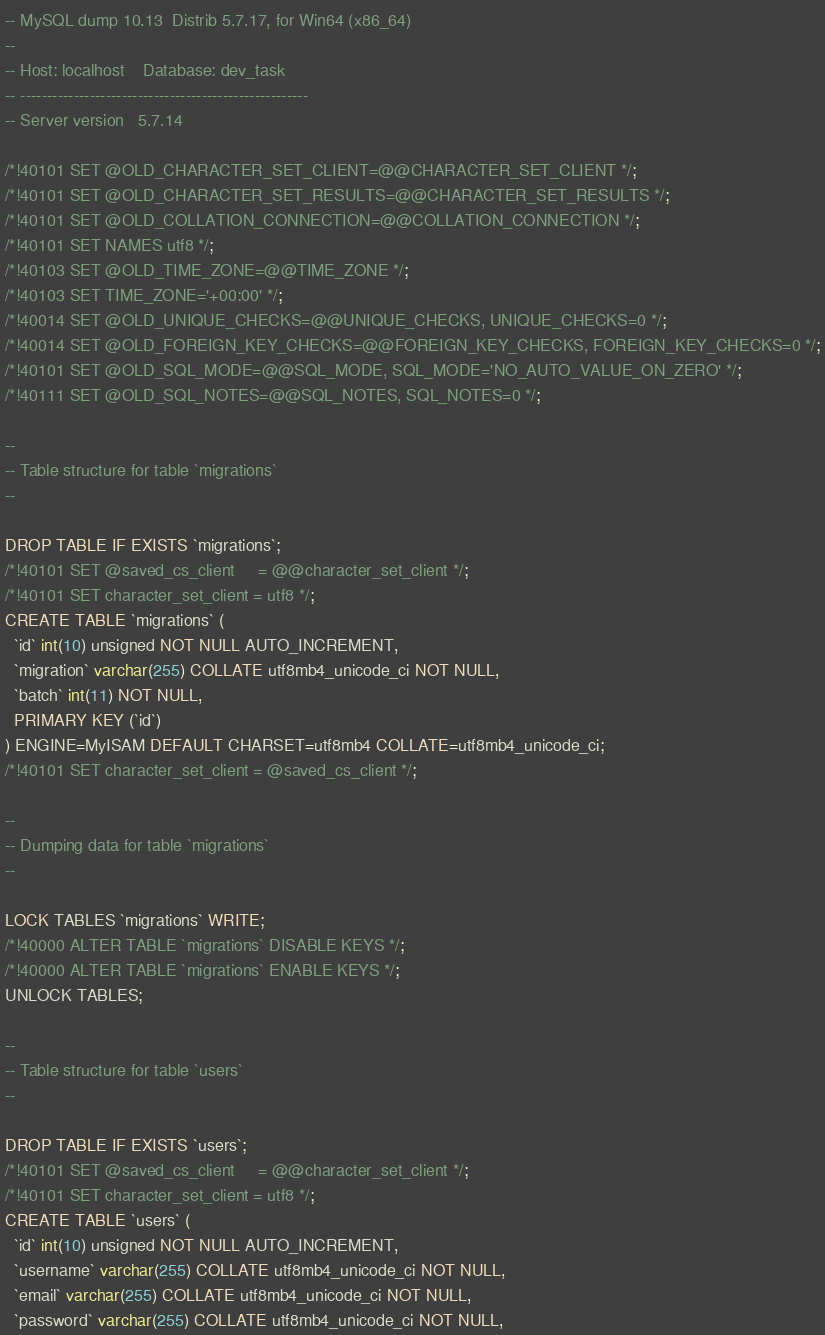Convert code to text. <code><loc_0><loc_0><loc_500><loc_500><_SQL_>-- MySQL dump 10.13  Distrib 5.7.17, for Win64 (x86_64)
--
-- Host: localhost    Database: dev_task
-- ------------------------------------------------------
-- Server version	5.7.14

/*!40101 SET @OLD_CHARACTER_SET_CLIENT=@@CHARACTER_SET_CLIENT */;
/*!40101 SET @OLD_CHARACTER_SET_RESULTS=@@CHARACTER_SET_RESULTS */;
/*!40101 SET @OLD_COLLATION_CONNECTION=@@COLLATION_CONNECTION */;
/*!40101 SET NAMES utf8 */;
/*!40103 SET @OLD_TIME_ZONE=@@TIME_ZONE */;
/*!40103 SET TIME_ZONE='+00:00' */;
/*!40014 SET @OLD_UNIQUE_CHECKS=@@UNIQUE_CHECKS, UNIQUE_CHECKS=0 */;
/*!40014 SET @OLD_FOREIGN_KEY_CHECKS=@@FOREIGN_KEY_CHECKS, FOREIGN_KEY_CHECKS=0 */;
/*!40101 SET @OLD_SQL_MODE=@@SQL_MODE, SQL_MODE='NO_AUTO_VALUE_ON_ZERO' */;
/*!40111 SET @OLD_SQL_NOTES=@@SQL_NOTES, SQL_NOTES=0 */;

--
-- Table structure for table `migrations`
--

DROP TABLE IF EXISTS `migrations`;
/*!40101 SET @saved_cs_client     = @@character_set_client */;
/*!40101 SET character_set_client = utf8 */;
CREATE TABLE `migrations` (
  `id` int(10) unsigned NOT NULL AUTO_INCREMENT,
  `migration` varchar(255) COLLATE utf8mb4_unicode_ci NOT NULL,
  `batch` int(11) NOT NULL,
  PRIMARY KEY (`id`)
) ENGINE=MyISAM DEFAULT CHARSET=utf8mb4 COLLATE=utf8mb4_unicode_ci;
/*!40101 SET character_set_client = @saved_cs_client */;

--
-- Dumping data for table `migrations`
--

LOCK TABLES `migrations` WRITE;
/*!40000 ALTER TABLE `migrations` DISABLE KEYS */;
/*!40000 ALTER TABLE `migrations` ENABLE KEYS */;
UNLOCK TABLES;

--
-- Table structure for table `users`
--

DROP TABLE IF EXISTS `users`;
/*!40101 SET @saved_cs_client     = @@character_set_client */;
/*!40101 SET character_set_client = utf8 */;
CREATE TABLE `users` (
  `id` int(10) unsigned NOT NULL AUTO_INCREMENT,
  `username` varchar(255) COLLATE utf8mb4_unicode_ci NOT NULL,
  `email` varchar(255) COLLATE utf8mb4_unicode_ci NOT NULL,
  `password` varchar(255) COLLATE utf8mb4_unicode_ci NOT NULL,</code> 